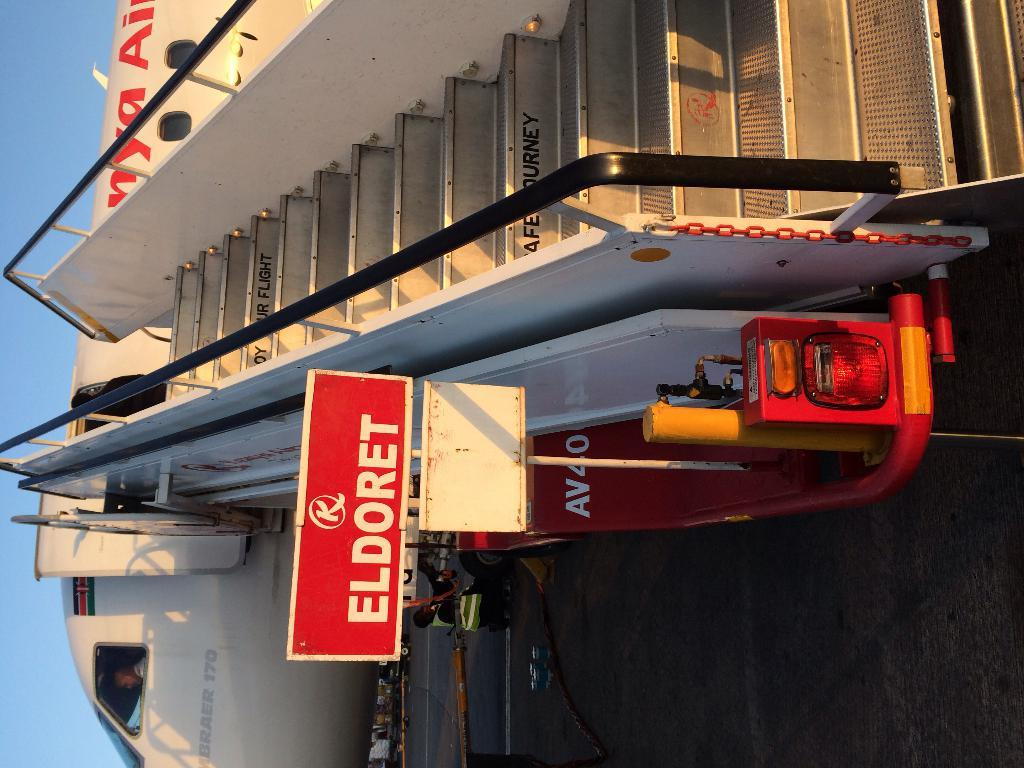<image>
Write a terse but informative summary of the picture. An Eldoret passenger jet has a stairway rolled up to it. 